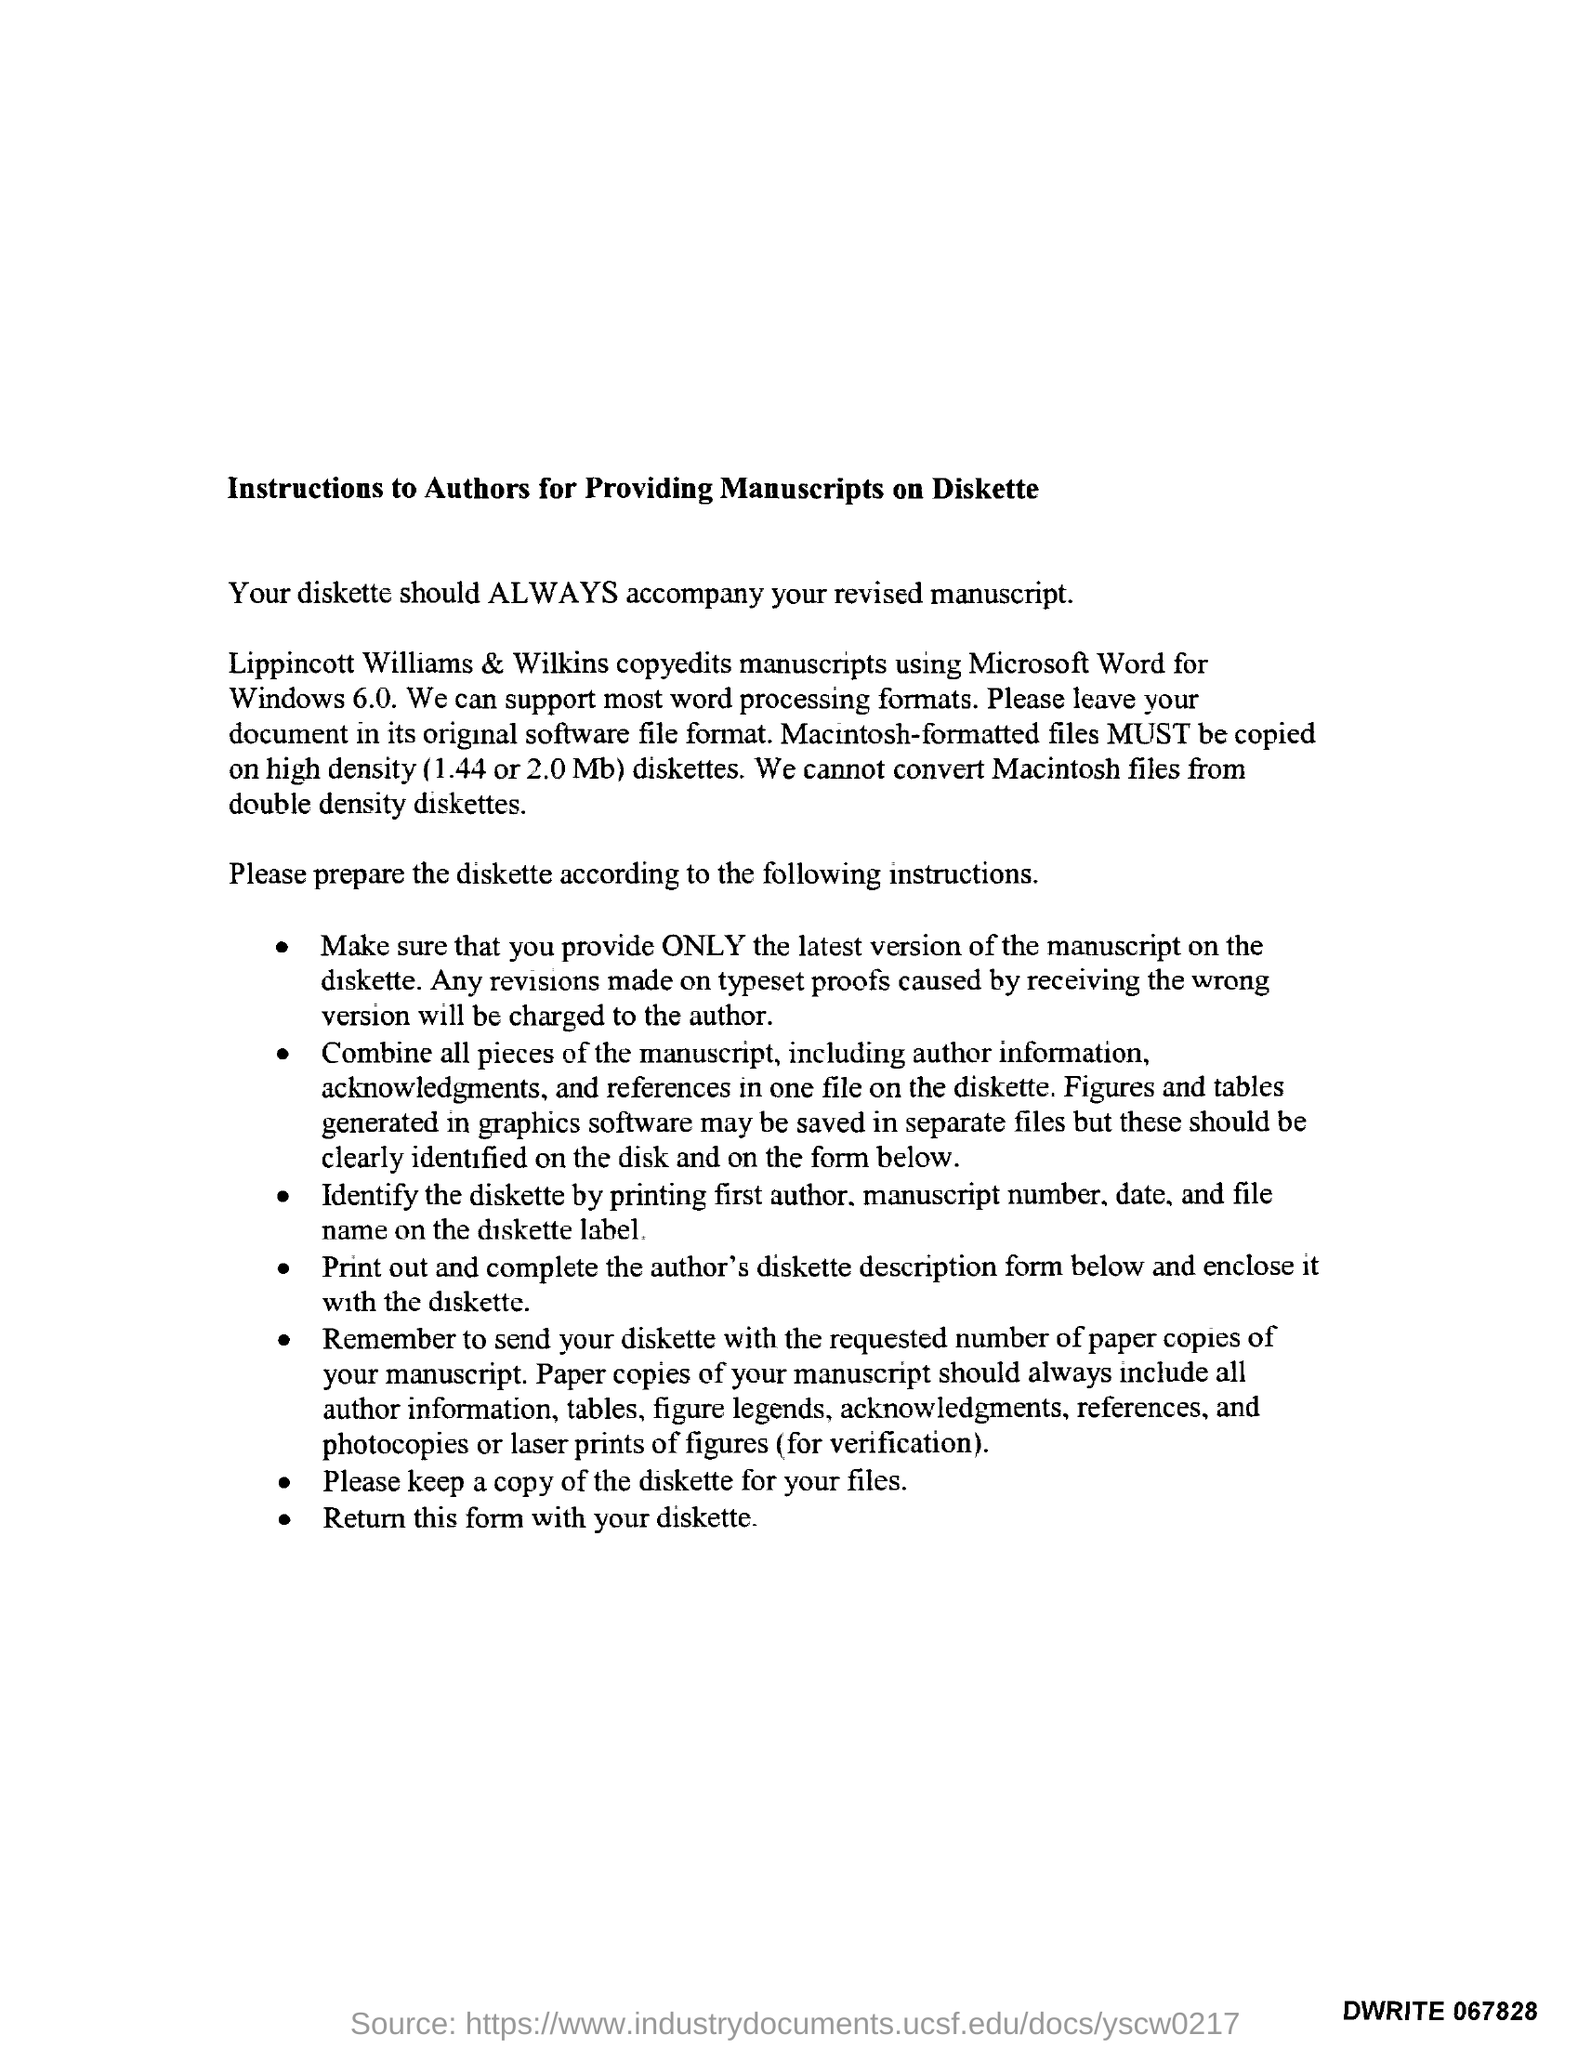What is the title of the document?
Keep it short and to the point. Instructions to Authors for Providing Manuscripts on Diskette. 